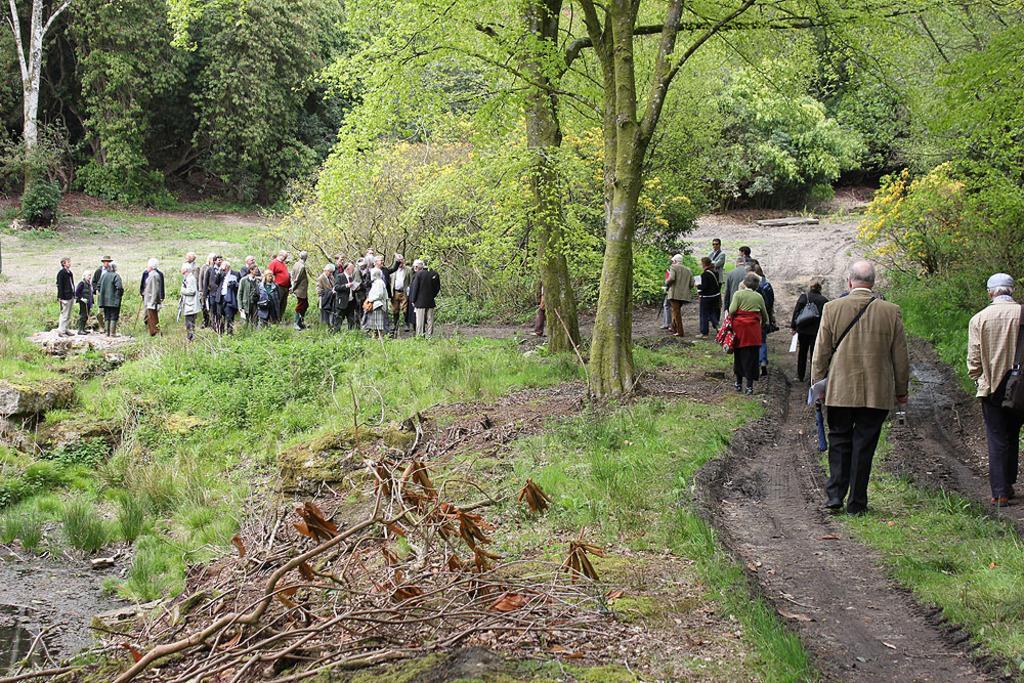Describe this image in one or two sentences. This picture describes about group of people, few are standing and few are walking, in the background we can see few plants and trees. 